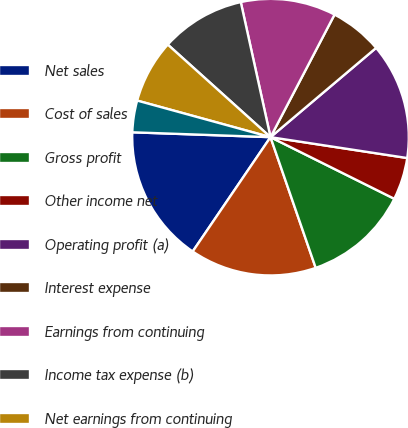Convert chart. <chart><loc_0><loc_0><loc_500><loc_500><pie_chart><fcel>Net sales<fcel>Cost of sales<fcel>Gross profit<fcel>Other income net<fcel>Operating profit (a)<fcel>Interest expense<fcel>Earnings from continuing<fcel>Income tax expense (b)<fcel>Net earnings from continuing<fcel>Net earnings from discontinued<nl><fcel>16.05%<fcel>14.81%<fcel>12.35%<fcel>4.94%<fcel>13.58%<fcel>6.17%<fcel>11.11%<fcel>9.88%<fcel>7.41%<fcel>3.7%<nl></chart> 